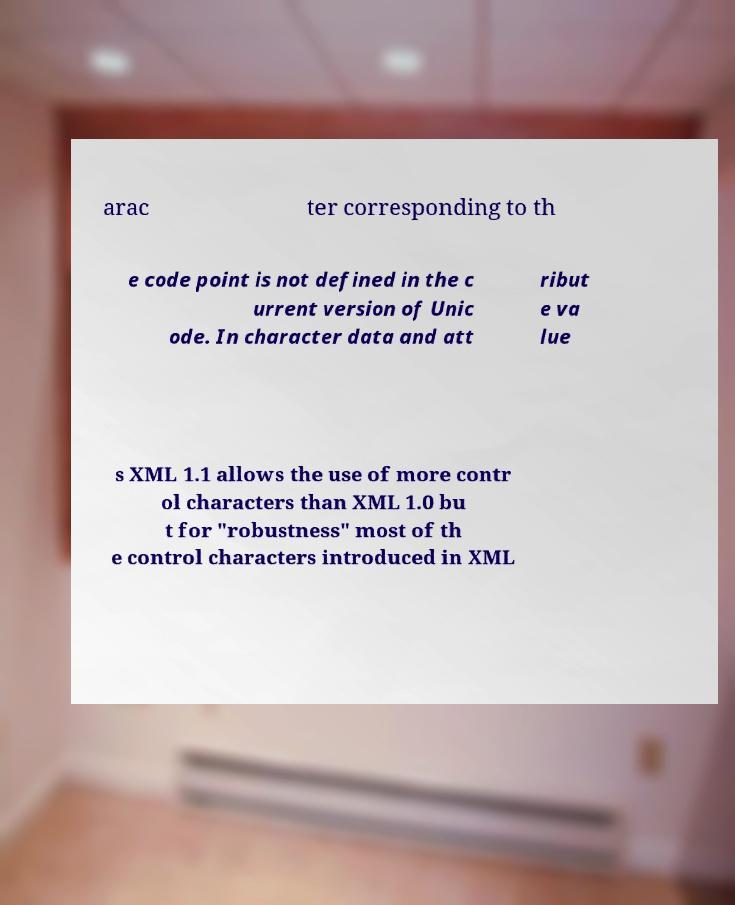Can you accurately transcribe the text from the provided image for me? arac ter corresponding to th e code point is not defined in the c urrent version of Unic ode. In character data and att ribut e va lue s XML 1.1 allows the use of more contr ol characters than XML 1.0 bu t for "robustness" most of th e control characters introduced in XML 